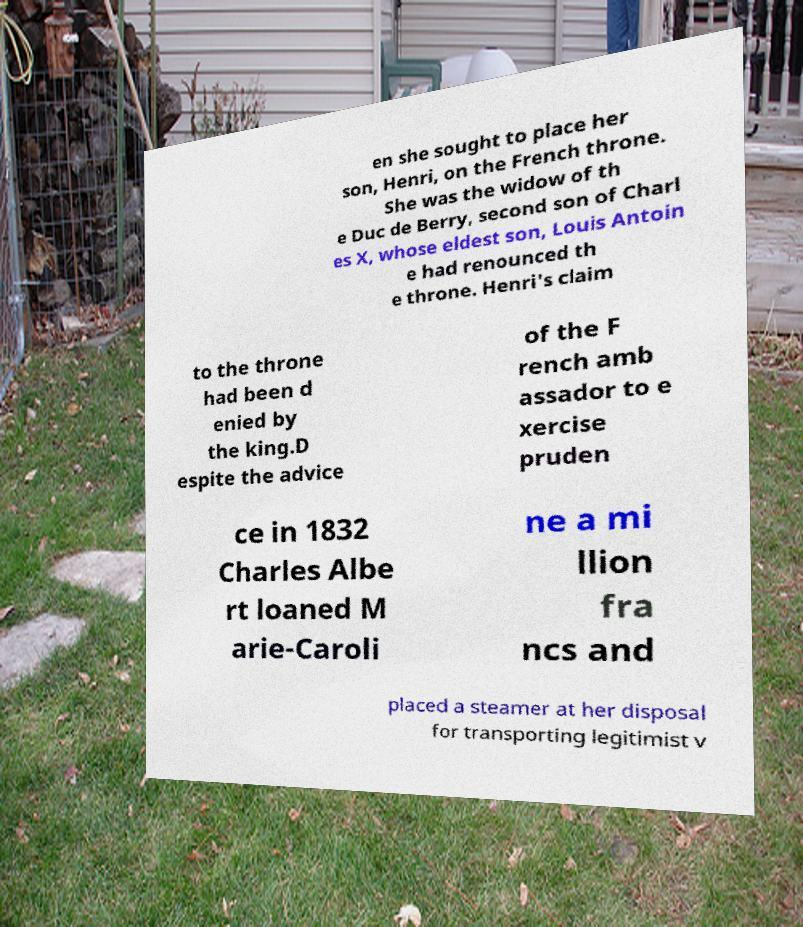For documentation purposes, I need the text within this image transcribed. Could you provide that? en she sought to place her son, Henri, on the French throne. She was the widow of th e Duc de Berry, second son of Charl es X, whose eldest son, Louis Antoin e had renounced th e throne. Henri's claim to the throne had been d enied by the king.D espite the advice of the F rench amb assador to e xercise pruden ce in 1832 Charles Albe rt loaned M arie-Caroli ne a mi llion fra ncs and placed a steamer at her disposal for transporting legitimist v 